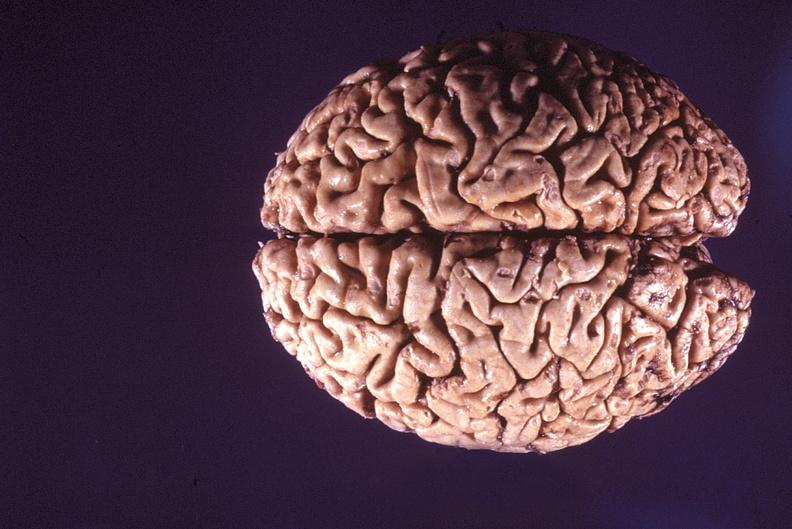does this typical lesion show normal brain?
Answer the question using a single word or phrase. No 